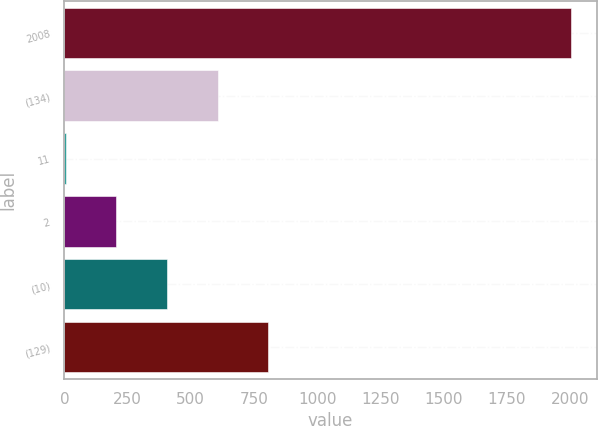<chart> <loc_0><loc_0><loc_500><loc_500><bar_chart><fcel>2008<fcel>(134)<fcel>11<fcel>2<fcel>(10)<fcel>(129)<nl><fcel>2006<fcel>606<fcel>6<fcel>206<fcel>406<fcel>806<nl></chart> 